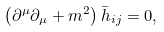Convert formula to latex. <formula><loc_0><loc_0><loc_500><loc_500>\left ( \partial ^ { \mu } \partial _ { \mu } + m ^ { 2 } \right ) { \bar { h } } _ { i j } = 0 ,</formula> 